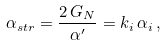Convert formula to latex. <formula><loc_0><loc_0><loc_500><loc_500>\alpha _ { s t r } = \frac { 2 \, G _ { N } } { \alpha ^ { \prime } } = k _ { i } \, \alpha _ { i } \, ,</formula> 